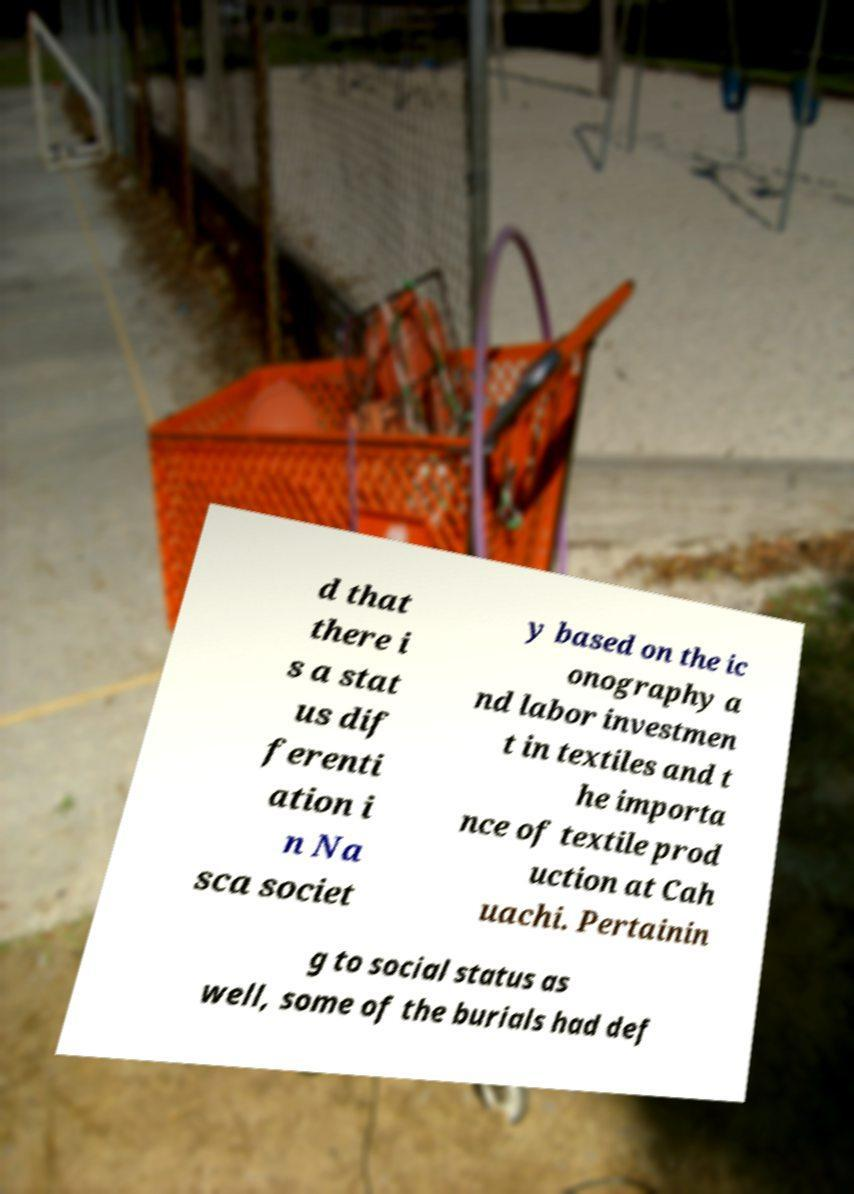There's text embedded in this image that I need extracted. Can you transcribe it verbatim? d that there i s a stat us dif ferenti ation i n Na sca societ y based on the ic onography a nd labor investmen t in textiles and t he importa nce of textile prod uction at Cah uachi. Pertainin g to social status as well, some of the burials had def 